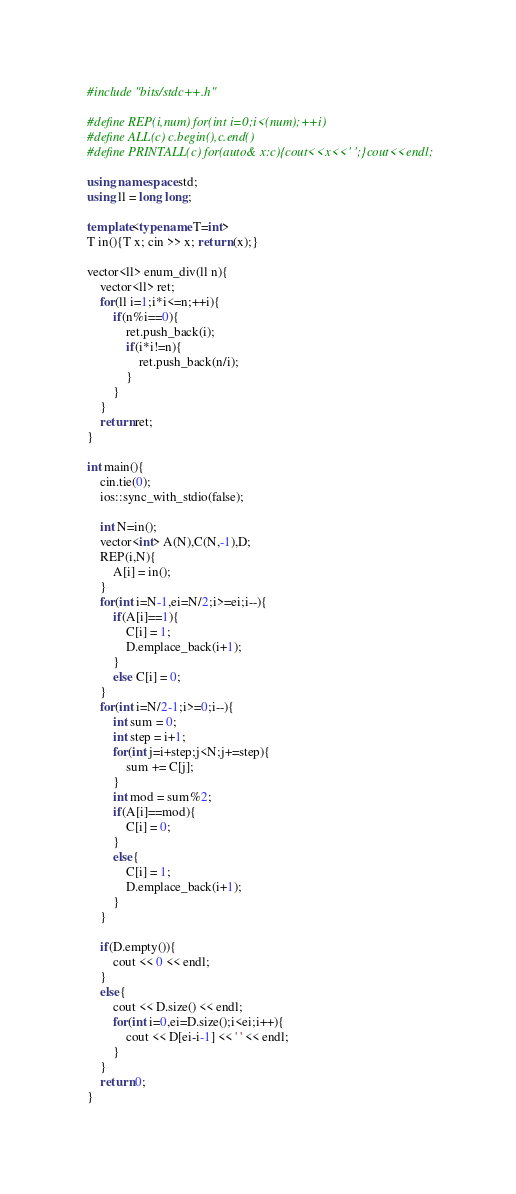Convert code to text. <code><loc_0><loc_0><loc_500><loc_500><_C++_>#include "bits/stdc++.h"

#define REP(i,num) for(int i=0;i<(num);++i)
#define ALL(c) c.begin(),c.end()
#define PRINTALL(c) for(auto& x:c){cout<<x<<' ';}cout<<endl;

using namespace std;
using ll = long long;

template<typename T=int>
T in(){T x; cin >> x; return (x);}

vector<ll> enum_div(ll n){
	vector<ll> ret;
	for(ll i=1;i*i<=n;++i){
		if(n%i==0){
			ret.push_back(i);
			if(i*i!=n){
				ret.push_back(n/i);
			}
		}
	}
	return ret;
}

int main(){
	cin.tie(0);
	ios::sync_with_stdio(false);

	int N=in();
	vector<int> A(N),C(N,-1),D;
	REP(i,N){
		A[i] = in();
	}
	for(int i=N-1,ei=N/2;i>=ei;i--){
		if(A[i]==1){
			C[i] = 1;
			D.emplace_back(i+1);
		}
		else C[i] = 0;
	}
	for(int i=N/2-1;i>=0;i--){
		int sum = 0;
		int step = i+1;
		for(int j=i+step;j<N;j+=step){
			sum += C[j];
		}
		int mod = sum%2;
		if(A[i]==mod){
			C[i] = 0;
		}
		else{
			C[i] = 1;
			D.emplace_back(i+1);
		}
	}

	if(D.empty()){
		cout << 0 << endl;
	}
	else{
		cout << D.size() << endl;
		for(int i=0,ei=D.size();i<ei;i++){
			cout << D[ei-i-1] << ' ' << endl;
		}
	}
	return 0;
}
</code> 